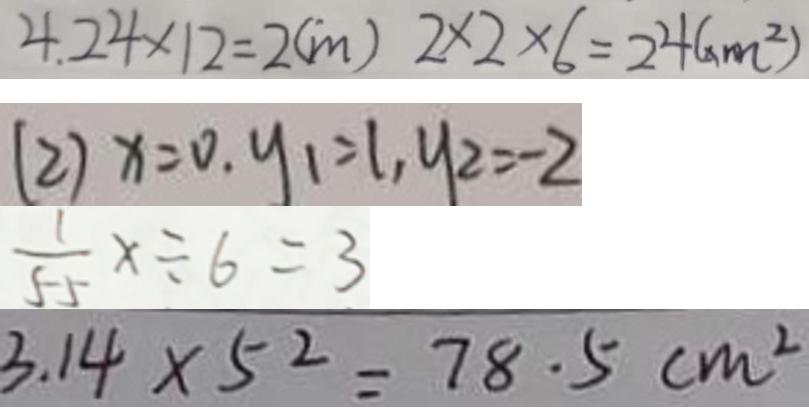<formula> <loc_0><loc_0><loc_500><loc_500>4 . 2 4 \times 1 2 = 2 ( m ) 2 \times 2 \times 6 = 2 4 ( x m ^ { 2 } ) 
 ( 2 ) x = 0 , y _ { 1 } = 1 , y _ { 2 } = - 2 
 \frac { 1 } { 5 5 } x \div 6 = 3 
 3 . 1 4 \times 5 ^ { 2 } = 7 8 . 5 c m ^ { 2 }</formula> 